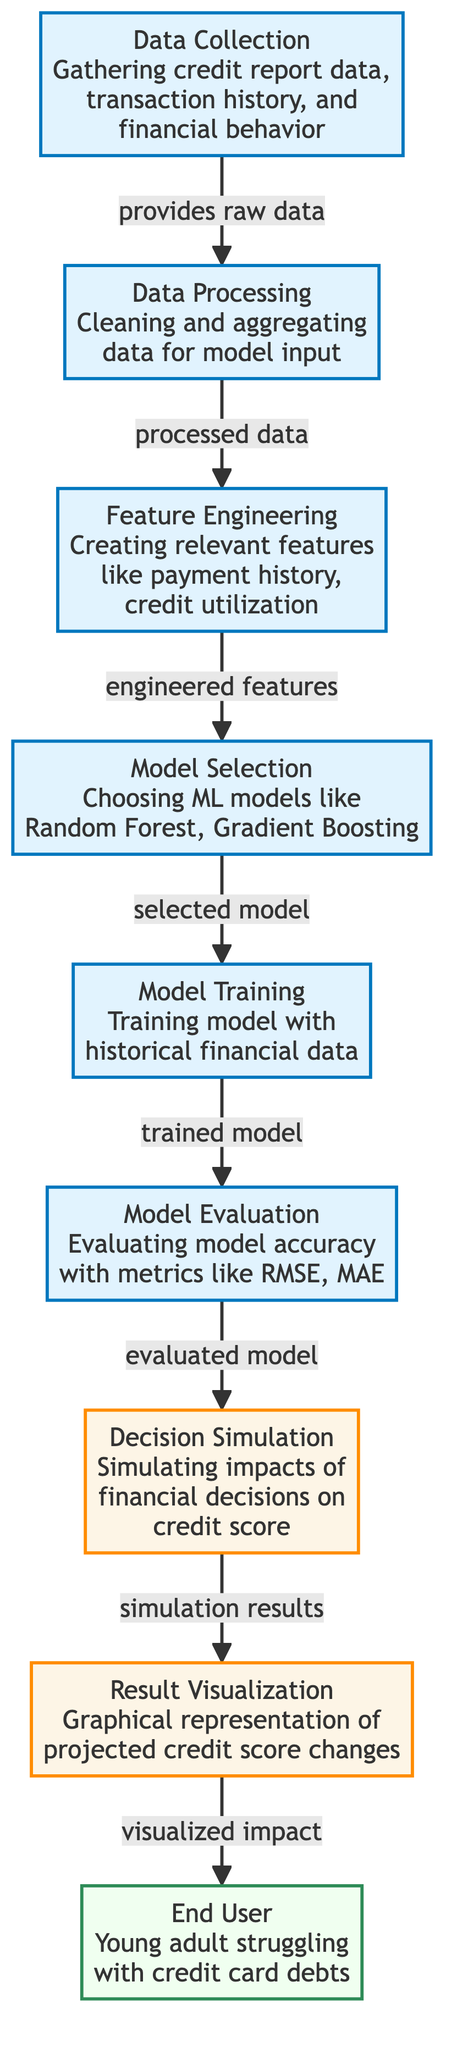What is the first step in the flow of the diagram? The flow starts with the "Data Collection" node, which indicates the first action taken to gather credit report data, transaction history, and financial behavior.
Answer: Data Collection How many main processes are shown in the diagram? There are six main processes in the diagram: Data Collection, Data Processing, Feature Engineering, Model Selection, Model Training, and Model Evaluation.
Answer: Six What does the "Decision Simulation" node represent in the context of the diagram? The "Decision Simulation" node represents the simulation of impacts that financial decisions will have on the credit score, based on the trained model.
Answer: Simulation of impacts Which node comes after "Model Evaluation"? The node that directly follows "Model Evaluation" in the flow is "Decision Simulation", indicating that the evaluation leads to simulating different decisions' effects.
Answer: Decision Simulation What type of model is chosen during the "Model Selection" phase? The models chosen during the "Model Selection" phase include options like Random Forest and Gradient Boosting, which are both popular machine learning algorithms.
Answer: Random Forest, Gradient Boosting What is the final output that the "End User" receives from the process? The final output received by the "End User" is a graphical representation of the projected credit score changes based on the financial decisions simulated.
Answer: Graphical representation Which node's output directly leads to "Result Visualization"? The output from the "Decision Simulation" node directly leads to "Result Visualization", showing the results of the simulated financial decisions.
Answer: Decision Simulation Why is "Feature Engineering" important in this diagram? "Feature Engineering" is crucial because it involves creating relevant features like payment history and credit utilization, which are necessary for the model to make accurate predictions about credit score impacts.
Answer: Creating relevant features How does the "Data Processing" contribute to the overall model? "Data Processing" contributes by cleaning and aggregating the raw data, preparing it to be used effectively in "Feature Engineering" and subsequent modeling steps.
Answer: Cleaning and aggregating data 